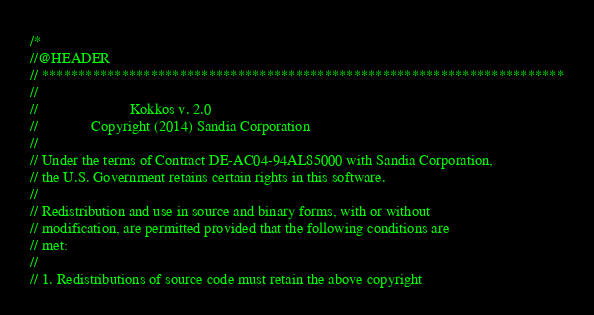Convert code to text. <code><loc_0><loc_0><loc_500><loc_500><_C++_>/*
//@HEADER
// ************************************************************************
//
//                        Kokkos v. 2.0
//              Copyright (2014) Sandia Corporation
//
// Under the terms of Contract DE-AC04-94AL85000 with Sandia Corporation,
// the U.S. Government retains certain rights in this software.
//
// Redistribution and use in source and binary forms, with or without
// modification, are permitted provided that the following conditions are
// met:
//
// 1. Redistributions of source code must retain the above copyright</code> 